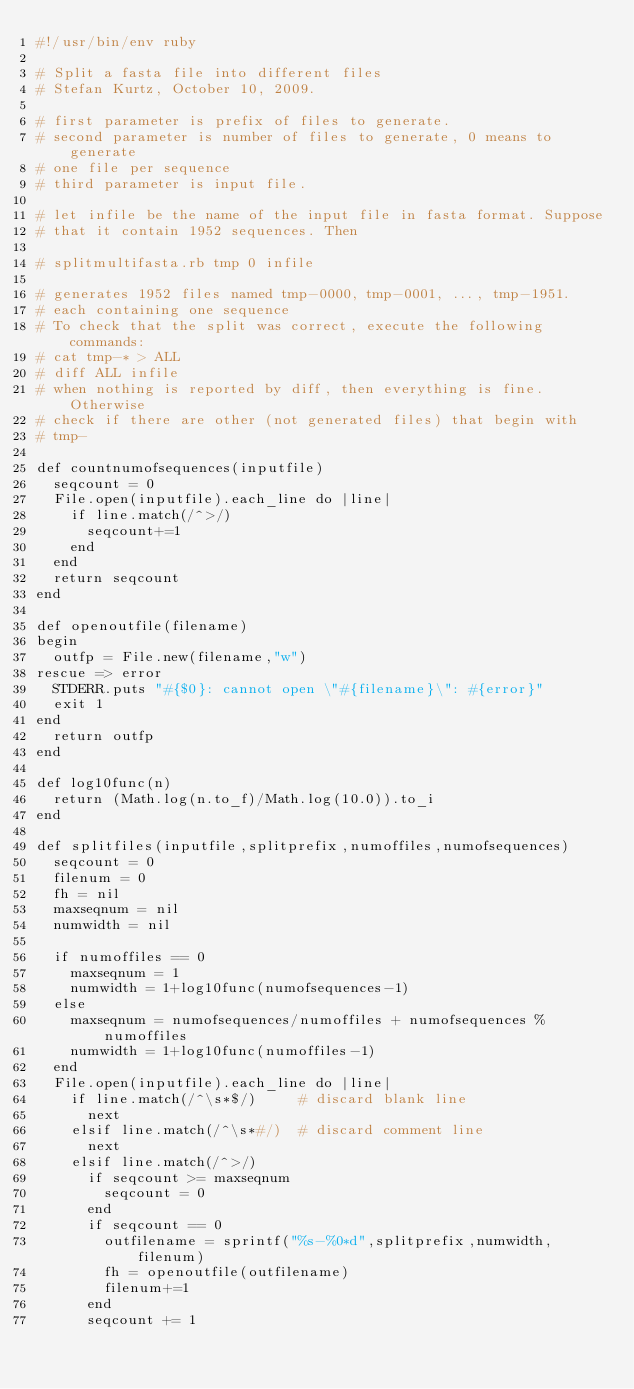Convert code to text. <code><loc_0><loc_0><loc_500><loc_500><_Ruby_>#!/usr/bin/env ruby

# Split a fasta file into different files
# Stefan Kurtz, October 10, 2009.

# first parameter is prefix of files to generate. 
# second parameter is number of files to generate, 0 means to generate
# one file per sequence
# third parameter is input file.

# let infile be the name of the input file in fasta format. Suppose 
# that it contain 1952 sequences. Then

# splitmultifasta.rb tmp 0 infile

# generates 1952 files named tmp-0000, tmp-0001, ..., tmp-1951.
# each containing one sequence
# To check that the split was correct, execute the following commands:
# cat tmp-* > ALL
# diff ALL infile
# when nothing is reported by diff, then everything is fine. Otherwise
# check if there are other (not generated files) that begin with
# tmp-

def countnumofsequences(inputfile)
  seqcount = 0
  File.open(inputfile).each_line do |line|
    if line.match(/^>/)
      seqcount+=1
    end
  end
  return seqcount
end

def openoutfile(filename)
begin
  outfp = File.new(filename,"w")
rescue => error
  STDERR.puts "#{$0}: cannot open \"#{filename}\": #{error}"
  exit 1
end
  return outfp
end

def log10func(n)
  return (Math.log(n.to_f)/Math.log(10.0)).to_i
end

def splitfiles(inputfile,splitprefix,numoffiles,numofsequences)
  seqcount = 0
  filenum = 0
  fh = nil
  maxseqnum = nil
  numwidth = nil

  if numoffiles == 0
    maxseqnum = 1
    numwidth = 1+log10func(numofsequences-1)
  else
    maxseqnum = numofsequences/numoffiles + numofsequences % numoffiles
    numwidth = 1+log10func(numoffiles-1)
  end
  File.open(inputfile).each_line do |line|
    if line.match(/^\s*$/)     # discard blank line
      next
    elsif line.match(/^\s*#/)  # discard comment line
      next
    elsif line.match(/^>/)
      if seqcount >= maxseqnum
        seqcount = 0
      end
      if seqcount == 0
        outfilename = sprintf("%s-%0*d",splitprefix,numwidth,filenum)
        fh = openoutfile(outfilename)
        filenum+=1
      end
      seqcount += 1</code> 